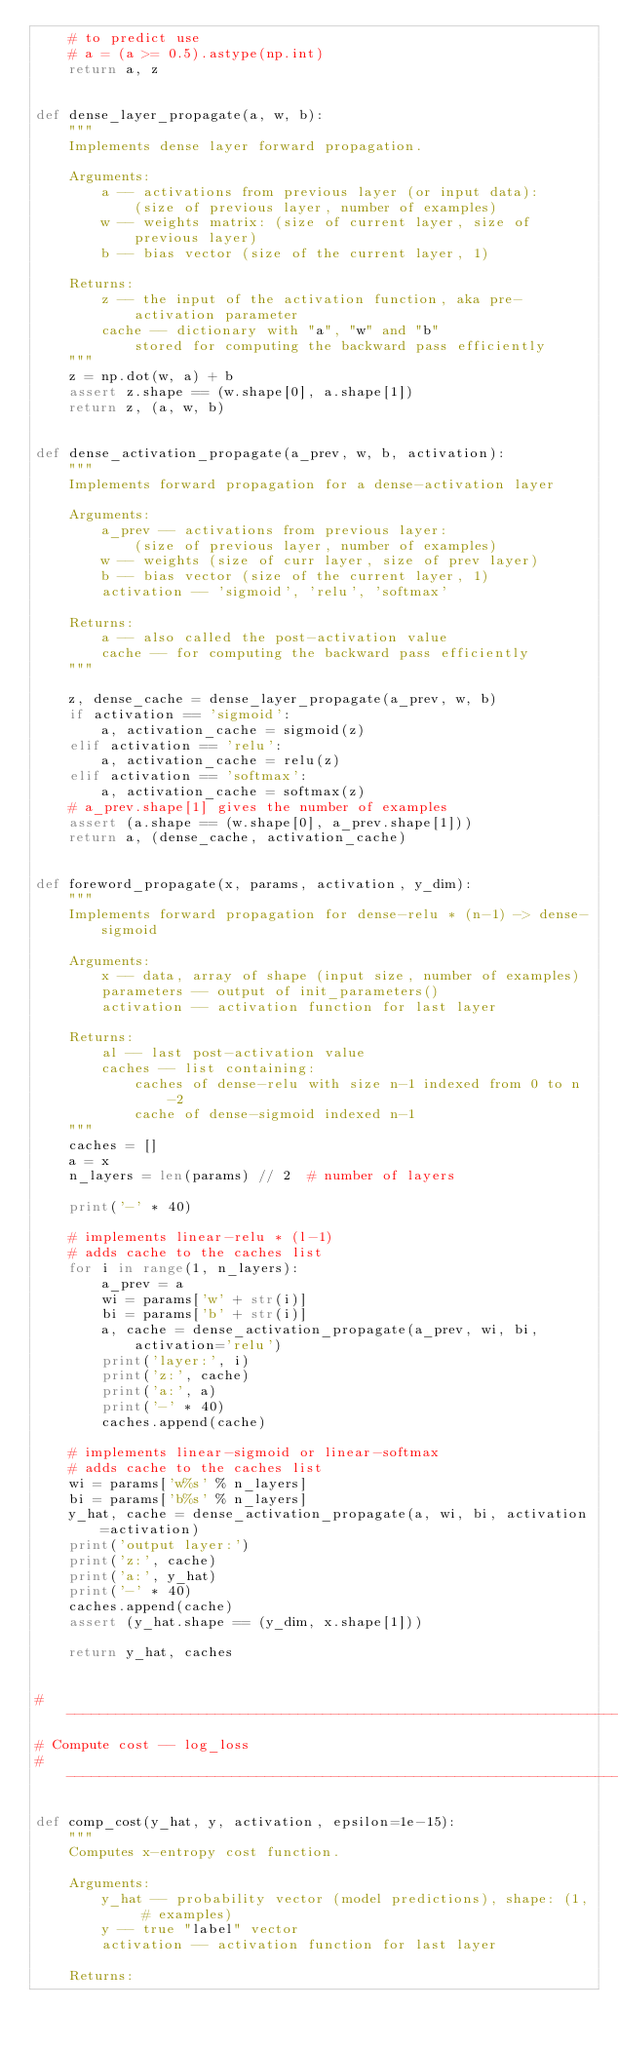Convert code to text. <code><loc_0><loc_0><loc_500><loc_500><_Python_>    # to predict use
    # a = (a >= 0.5).astype(np.int)
    return a, z


def dense_layer_propagate(a, w, b):
    """
    Implements dense layer forward propagation.

    Arguments:
        a -- activations from previous layer (or input data):
            (size of previous layer, number of examples)
        w -- weights matrix: (size of current layer, size of previous layer)
        b -- bias vector (size of the current layer, 1)

    Returns:
        z -- the input of the activation function, aka pre-activation parameter
        cache -- dictionary with "a", "w" and "b"
            stored for computing the backward pass efficiently
    """
    z = np.dot(w, a) + b
    assert z.shape == (w.shape[0], a.shape[1])
    return z, (a, w, b)


def dense_activation_propagate(a_prev, w, b, activation):
    """
    Implements forward propagation for a dense-activation layer

    Arguments:
        a_prev -- activations from previous layer:
            (size of previous layer, number of examples)
        w -- weights (size of curr layer, size of prev layer)
        b -- bias vector (size of the current layer, 1)
        activation -- 'sigmoid', 'relu', 'softmax'

    Returns:
        a -- also called the post-activation value
        cache -- for computing the backward pass efficiently
    """

    z, dense_cache = dense_layer_propagate(a_prev, w, b)
    if activation == 'sigmoid':
        a, activation_cache = sigmoid(z)
    elif activation == 'relu':
        a, activation_cache = relu(z)
    elif activation == 'softmax':
        a, activation_cache = softmax(z)
    # a_prev.shape[1] gives the number of examples
    assert (a.shape == (w.shape[0], a_prev.shape[1]))
    return a, (dense_cache, activation_cache)


def foreword_propagate(x, params, activation, y_dim):
    """
    Implements forward propagation for dense-relu * (n-1) -> dense-sigmoid

    Arguments:
        x -- data, array of shape (input size, number of examples)
        parameters -- output of init_parameters()
        activation -- activation function for last layer

    Returns:
        al -- last post-activation value
        caches -- list containing:
            caches of dense-relu with size n-1 indexed from 0 to n-2
            cache of dense-sigmoid indexed n-1
    """
    caches = []
    a = x
    n_layers = len(params) // 2  # number of layers

    print('-' * 40)

    # implements linear-relu * (l-1)
    # adds cache to the caches list
    for i in range(1, n_layers):
        a_prev = a
        wi = params['w' + str(i)]
        bi = params['b' + str(i)]
        a, cache = dense_activation_propagate(a_prev, wi, bi, activation='relu')
        print('layer:', i)
        print('z:', cache)
        print('a:', a)
        print('-' * 40)
        caches.append(cache)

    # implements linear-sigmoid or linear-softmax
    # adds cache to the caches list
    wi = params['w%s' % n_layers]
    bi = params['b%s' % n_layers]
    y_hat, cache = dense_activation_propagate(a, wi, bi, activation=activation)
    print('output layer:')
    print('z:', cache)
    print('a:', y_hat)
    print('-' * 40)
    caches.append(cache)
    assert (y_hat.shape == (y_dim, x.shape[1]))

    return y_hat, caches


# ----------------------------------------------------------------------
# Compute cost -- log_loss
# ----------------------------------------------------------------------

def comp_cost(y_hat, y, activation, epsilon=1e-15):
    """
    Computes x-entropy cost function.

    Arguments:
        y_hat -- probability vector (model predictions), shape: (1, # examples)
        y -- true "label" vector
        activation -- activation function for last layer

    Returns:</code> 